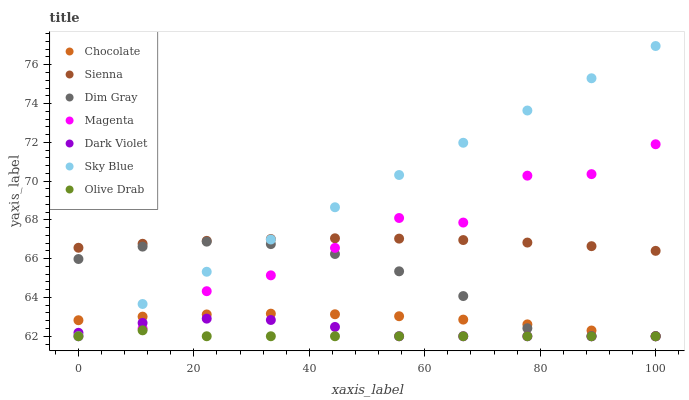Does Olive Drab have the minimum area under the curve?
Answer yes or no. Yes. Does Sky Blue have the maximum area under the curve?
Answer yes or no. Yes. Does Dark Violet have the minimum area under the curve?
Answer yes or no. No. Does Dark Violet have the maximum area under the curve?
Answer yes or no. No. Is Sky Blue the smoothest?
Answer yes or no. Yes. Is Magenta the roughest?
Answer yes or no. Yes. Is Dark Violet the smoothest?
Answer yes or no. No. Is Dark Violet the roughest?
Answer yes or no. No. Does Dim Gray have the lowest value?
Answer yes or no. Yes. Does Sienna have the lowest value?
Answer yes or no. No. Does Sky Blue have the highest value?
Answer yes or no. Yes. Does Dark Violet have the highest value?
Answer yes or no. No. Is Dark Violet less than Sienna?
Answer yes or no. Yes. Is Sienna greater than Dark Violet?
Answer yes or no. Yes. Does Dark Violet intersect Sky Blue?
Answer yes or no. Yes. Is Dark Violet less than Sky Blue?
Answer yes or no. No. Is Dark Violet greater than Sky Blue?
Answer yes or no. No. Does Dark Violet intersect Sienna?
Answer yes or no. No. 